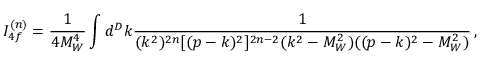<formula> <loc_0><loc_0><loc_500><loc_500>I _ { 4 f } ^ { ( n ) } = \frac { 1 } { 4 M _ { W } ^ { 4 } } \int d ^ { D } k \frac { 1 } { ( k ^ { 2 } ) ^ { 2 n } [ ( p - k ) ^ { 2 } ] ^ { 2 n - 2 } ( k ^ { 2 } - M _ { W } ^ { 2 } ) ( ( p - k ) ^ { 2 } - M _ { W } ^ { 2 } ) } \, ,</formula> 